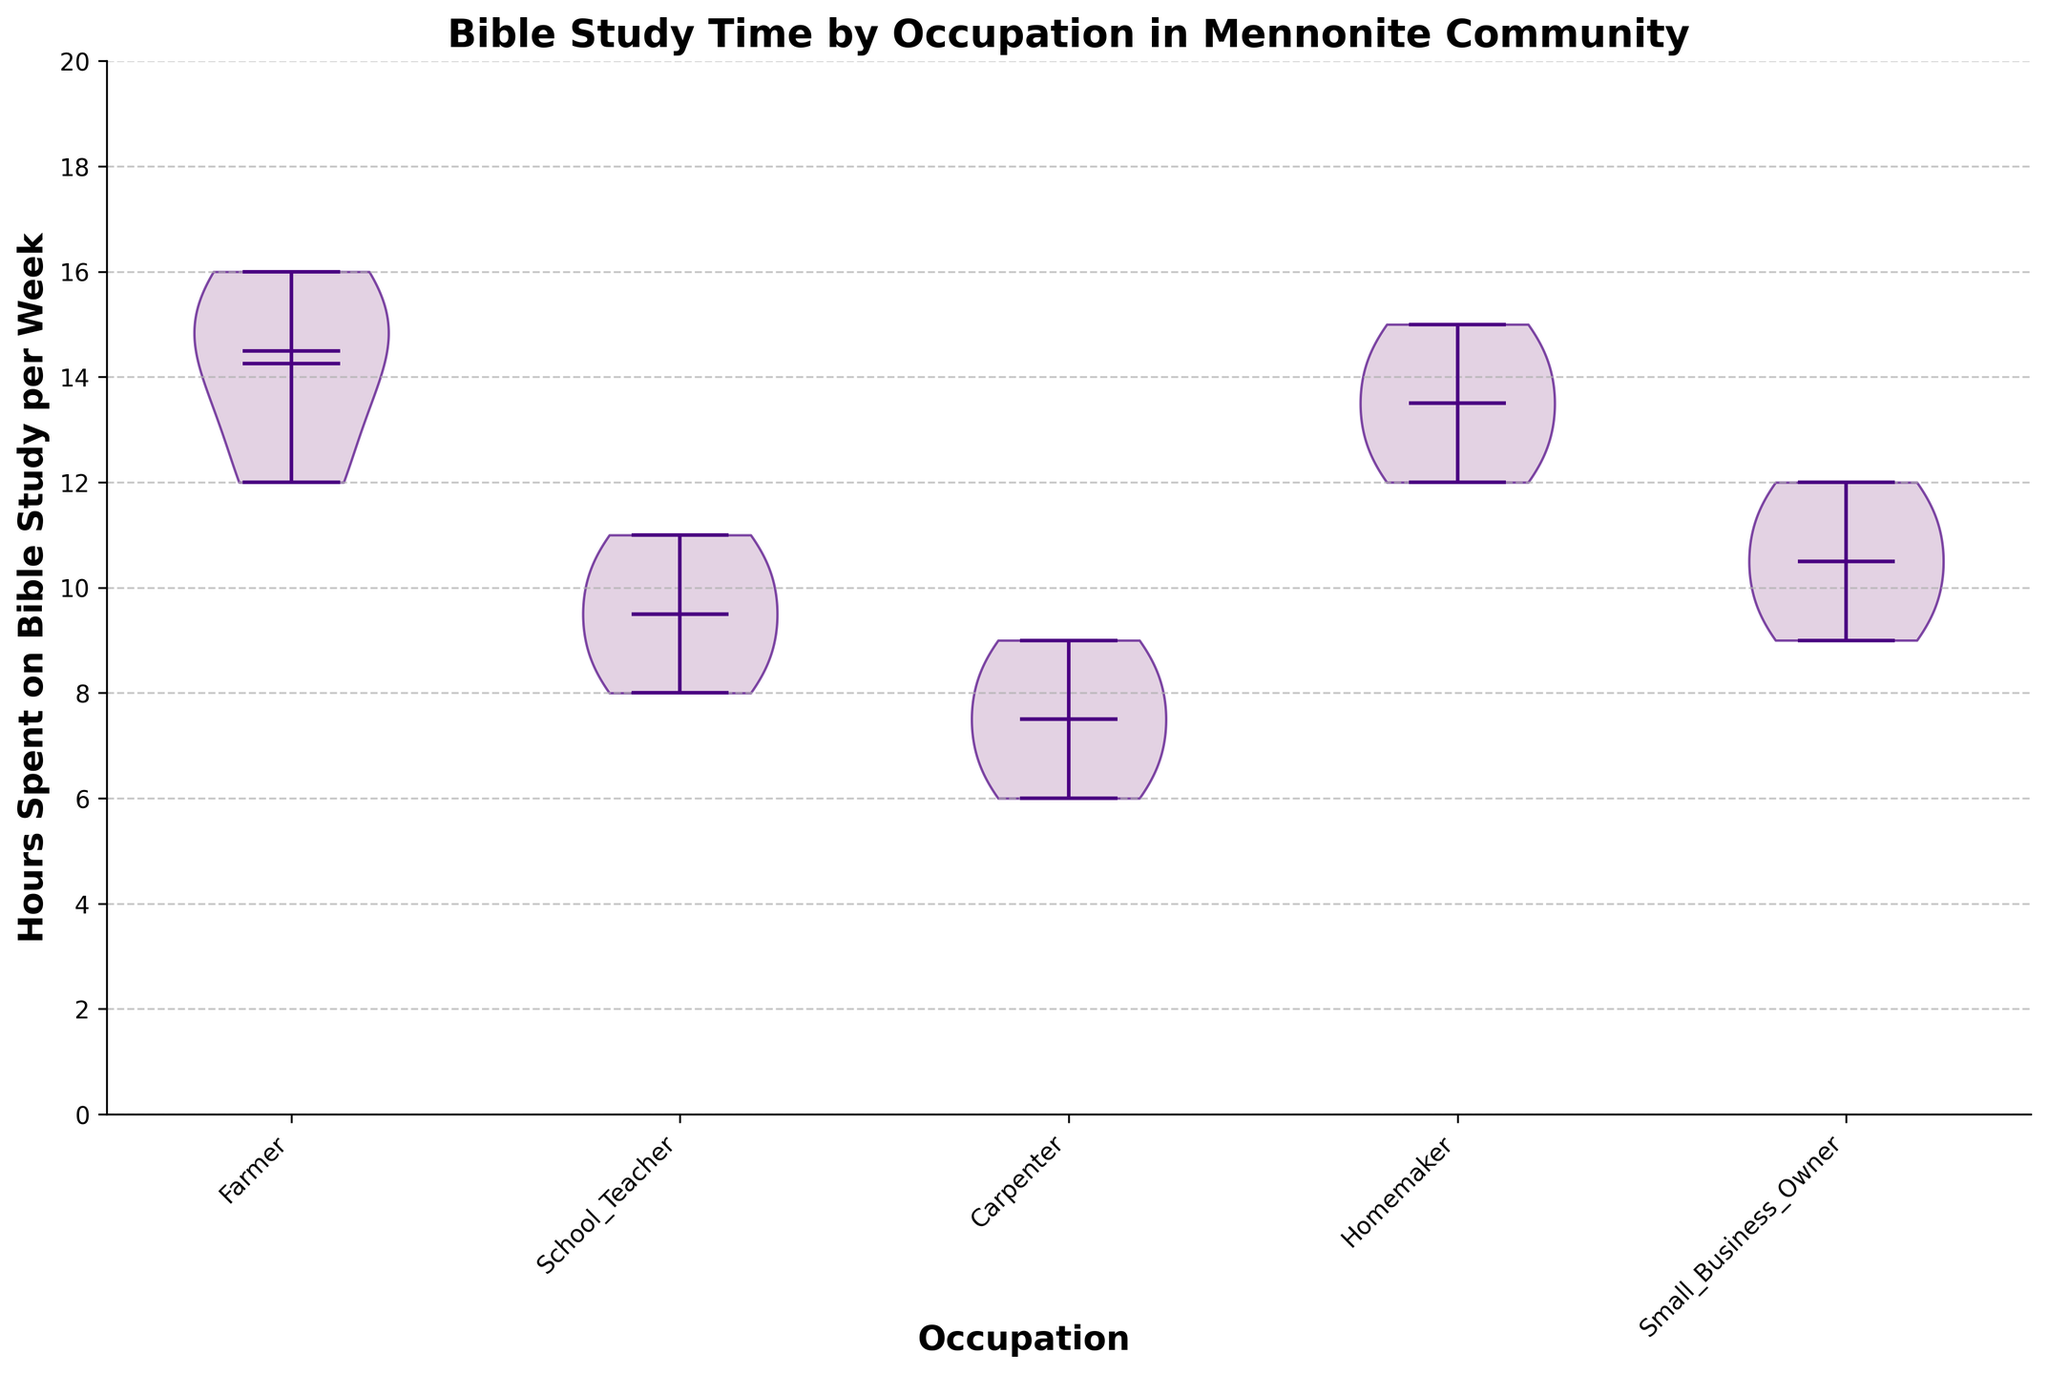what is the title of the figure? The title of the figure is usually found at the top and summarizes the central focus or content. According to the code, the title is "Bible Study Time by Occupation in Mennonite Community".
Answer: Bible Study Time by Occupation in Mennonite Community How many occupations are compared in the figure? The number of unique occupation categories can be determined by counting the splits in the x-axis. The code uses the unique values from the 'Occupation' column, resulting in five categories.
Answer: 5 Which occupation has the highest mean hours of Bible study? The violin parts indicate the mean with a marker. By comparing these markers among the five categories, the one with the highest mean can be identified. Farmers have the highest mean Bible study hours per week.
Answer: Farmers What's the range of hours spent on Bible study for school teachers? The range is given by the distance between the minimum and maximum values at the ends of the violin plot for school teachers. For school teachers, the minimum is 8 and the maximum is 11.
Answer: 8 to 11 Compare the median hours spent on Bible study between homemakers and small business owners. Medians are indicated by a central line in each violin plot. By comparing the median lines of homemakers and small business owners, homemakers have a median closer to 14 while small business owners have a median of around 10.5.
Answer: Homemakers have a higher median Which occupation shows the widest spread in hours spent on Bible study? The spread or variability can be assessed by the width of the violin plot. Farmers have the widest spread, indicating a larger range of hours spent on Bible study.
Answer: Farmers What is the color used for the edges of the violin parts? The violin parts are customized to have a specific edge color, which is described as '#4B0082' in the code. This color appears as a shade of indigo.
Answer: Indigo Do any occupations have the same mean hours of Bible study? By observing the markers for the mean hours in each violin plot, none of the occupations have the same mean, as each marker is at a different height.
Answer: No What is unique about the violin plot of carpenters compared to the others? The carpenter's violin plot shows a comparatively more uniform shape, suggesting their hours are more consistently distributed with less variability.
Answer: More consistent distribution 